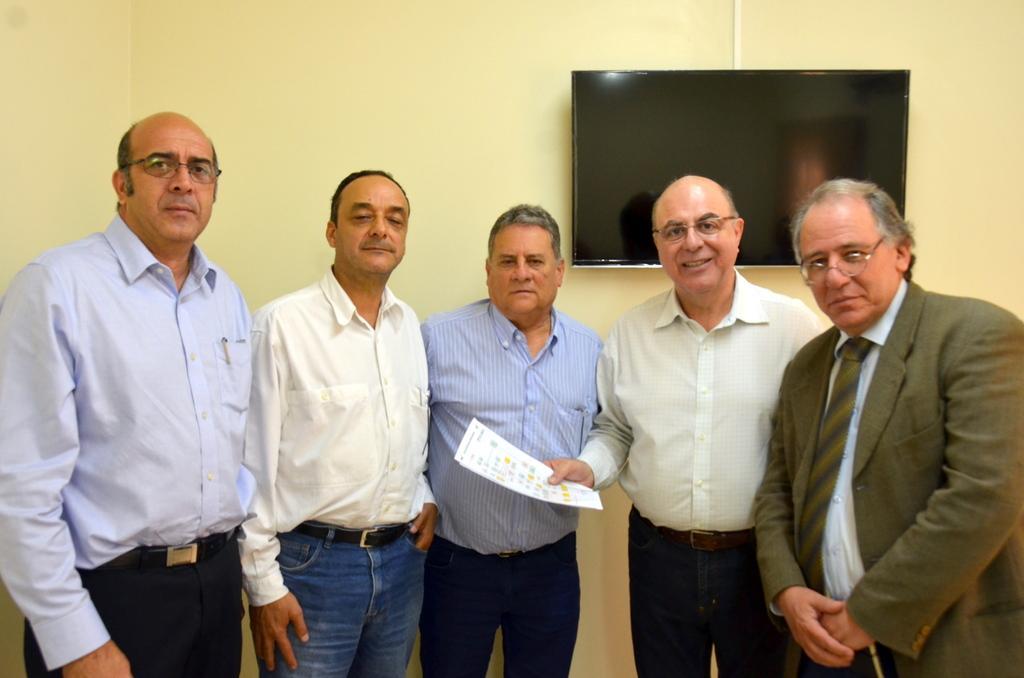How would you summarize this image in a sentence or two? In this image there are five men standing and one man is holding papers in his hand, in the background there is a wall for that wall there is a TV. 